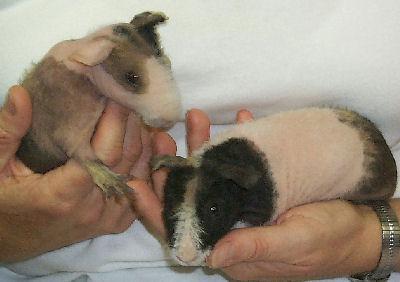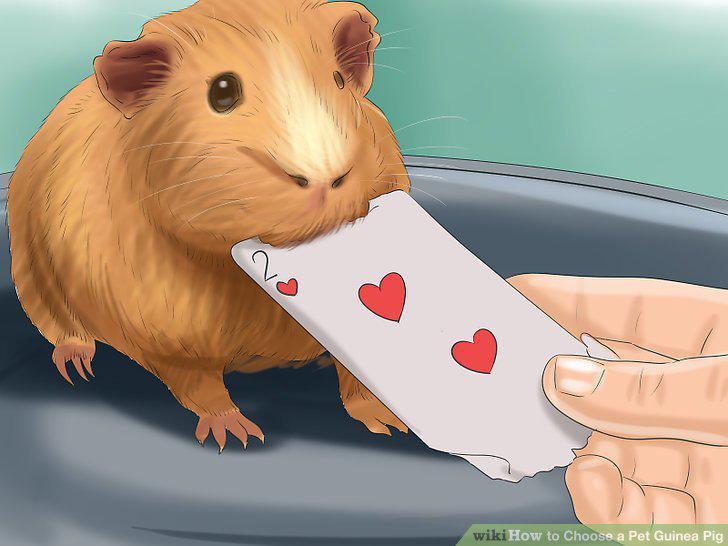The first image is the image on the left, the second image is the image on the right. Evaluate the accuracy of this statement regarding the images: "Each image shows two pet rodents on shredded-type bedding.". Is it true? Answer yes or no. No. 